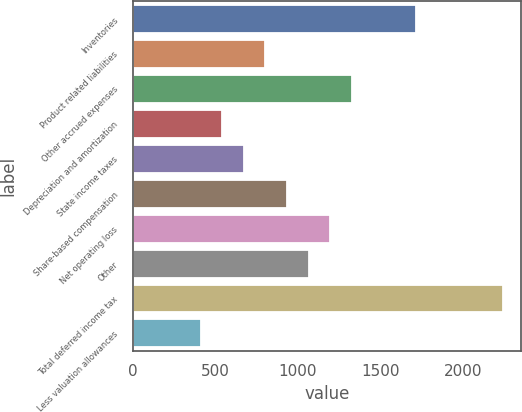Convert chart to OTSL. <chart><loc_0><loc_0><loc_500><loc_500><bar_chart><fcel>Inventories<fcel>Product related liabilities<fcel>Other accrued expenses<fcel>Depreciation and amortization<fcel>State income taxes<fcel>Share-based compensation<fcel>Net operating loss<fcel>Other<fcel>Total deferred income tax<fcel>Less valuation allowances<nl><fcel>1719<fcel>802<fcel>1326<fcel>540<fcel>671<fcel>933<fcel>1195<fcel>1064<fcel>2243<fcel>409<nl></chart> 